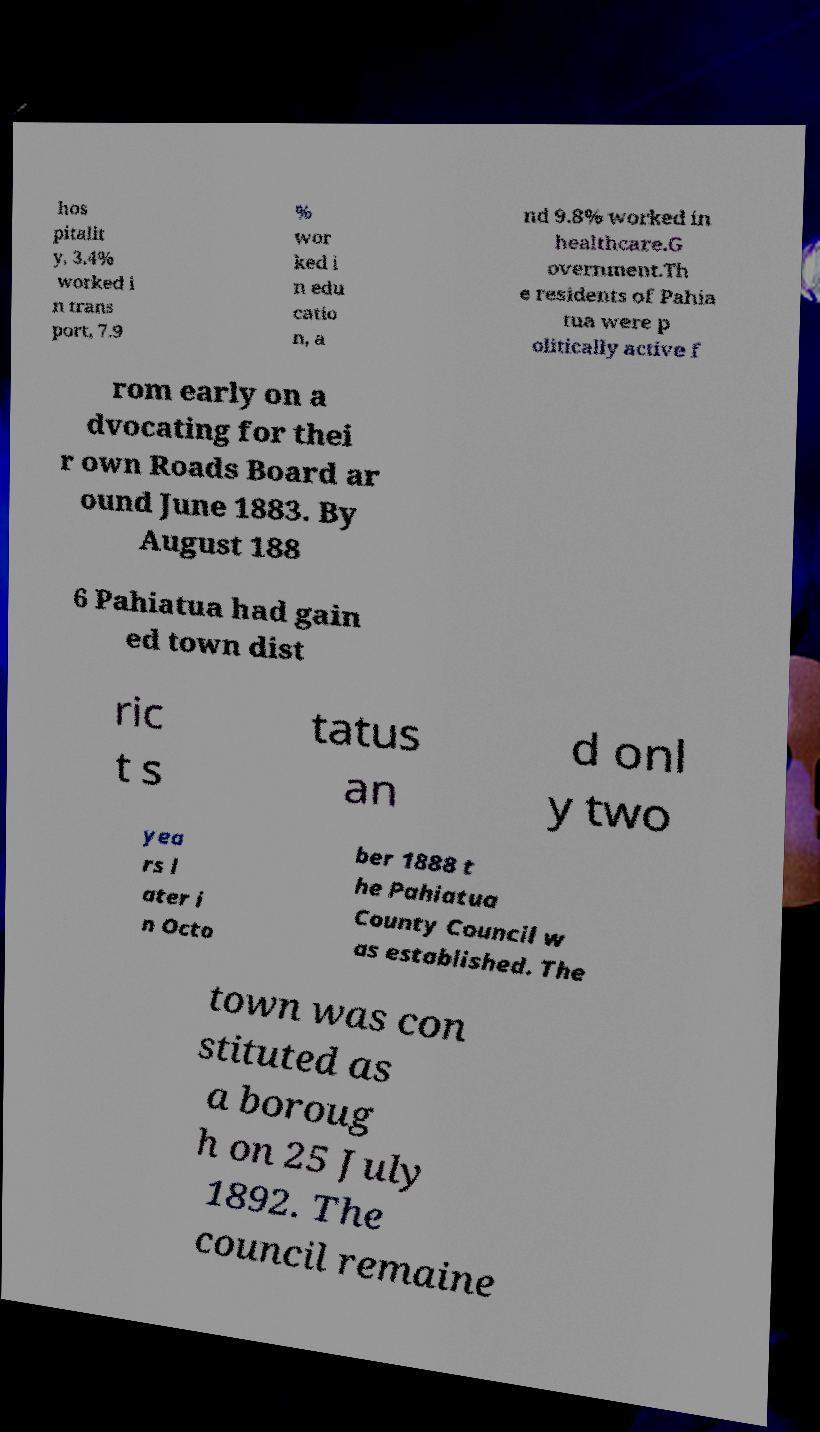I need the written content from this picture converted into text. Can you do that? hos pitalit y, 3.4% worked i n trans port, 7.9 % wor ked i n edu catio n, a nd 9.8% worked in healthcare.G overnment.Th e residents of Pahia tua were p olitically active f rom early on a dvocating for thei r own Roads Board ar ound June 1883. By August 188 6 Pahiatua had gain ed town dist ric t s tatus an d onl y two yea rs l ater i n Octo ber 1888 t he Pahiatua County Council w as established. The town was con stituted as a boroug h on 25 July 1892. The council remaine 